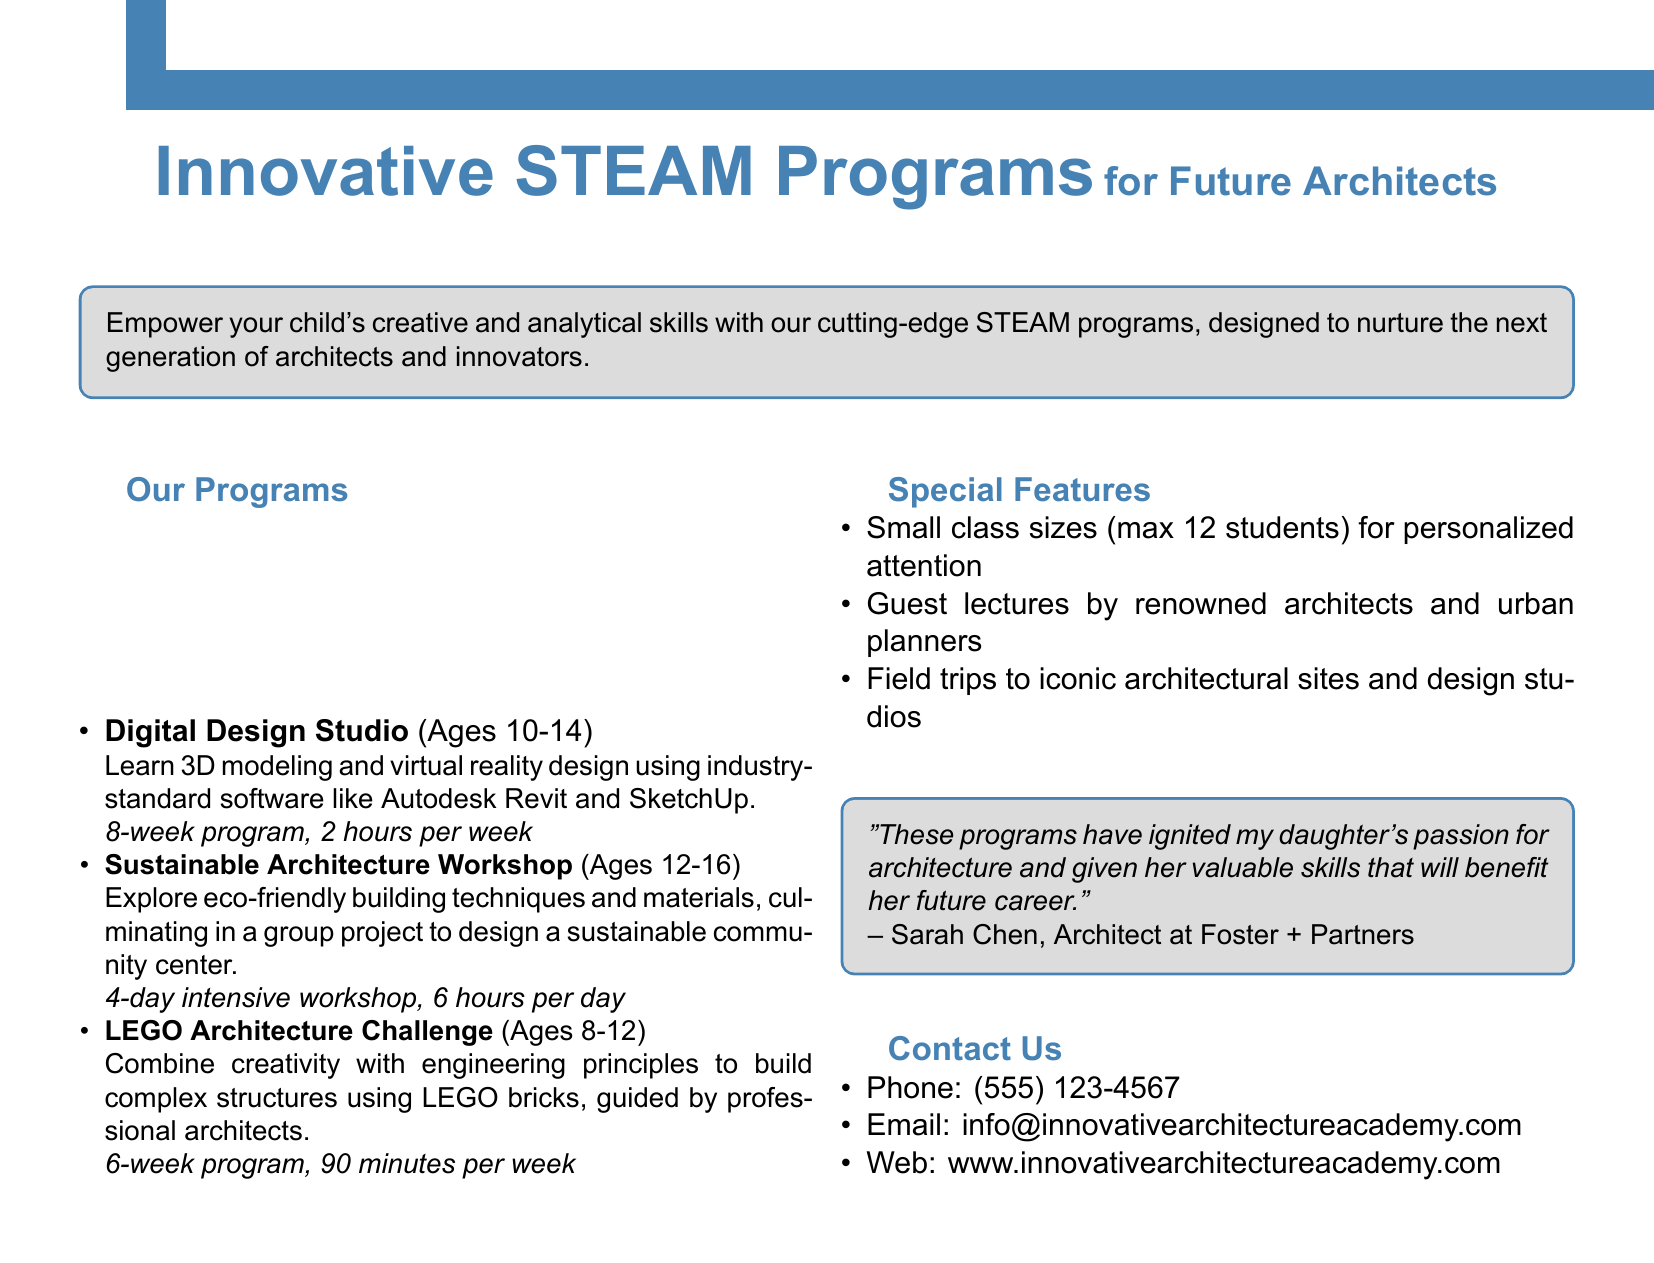What is the age range for the Digital Design Studio program? The age range is specified in the document, which is from ages 10 to 14.
Answer: Ages 10-14 How many hours per week is the Digital Design Studio program conducted? The document states that this program runs for 2 hours per week.
Answer: 2 hours per week What is the duration of the Sustainable Architecture Workshop? The document provides that this workshop lasts for 4 days.
Answer: 4 days How many maximum students are in each class? The document states that the maximum number of students per class is 12.
Answer: 12 students What type of material will be used in the LEGO Architecture Challenge? The document specifies that LEGO bricks will be used during this challenge.
Answer: LEGO bricks Why do the programs appeal to parents with children interested in architecture? The document describes features such as personalized attention, guest lectures, and field trips that cater to children's interests in architecture.
Answer: Personalized attention, guest lectures, and field trips What is the contact phone number for inquiries? The phone number for inquiries is included in the contact section of the document.
Answer: (555) 123-4567 What is a guest feature mentioned in the programs? The document highlights guest lectures by renowned architects and urban planners as a special feature.
Answer: Guest lectures by renowned architects What feedback is provided about the programs? A testimonial in the document gives positive feedback, stating the programs ignited a child's passion for architecture.
Answer: Ignited my daughter's passion for architecture 